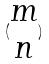<formula> <loc_0><loc_0><loc_500><loc_500>( \begin{matrix} m \\ n \end{matrix} )</formula> 